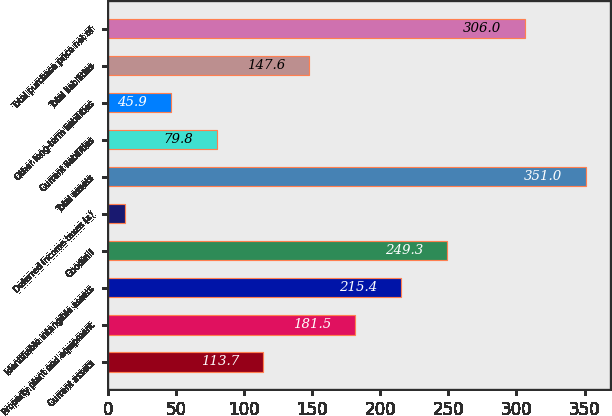Convert chart. <chart><loc_0><loc_0><loc_500><loc_500><bar_chart><fcel>Current assets<fcel>Property plant and equipment<fcel>Identifiable intangible assets<fcel>Goodwill<fcel>Deferred income taxes (a)<fcel>Total assets<fcel>Current liabilities<fcel>Other long-term liabilities<fcel>Total liabilities<fcel>Total purchase price net of<nl><fcel>113.7<fcel>181.5<fcel>215.4<fcel>249.3<fcel>12<fcel>351<fcel>79.8<fcel>45.9<fcel>147.6<fcel>306<nl></chart> 